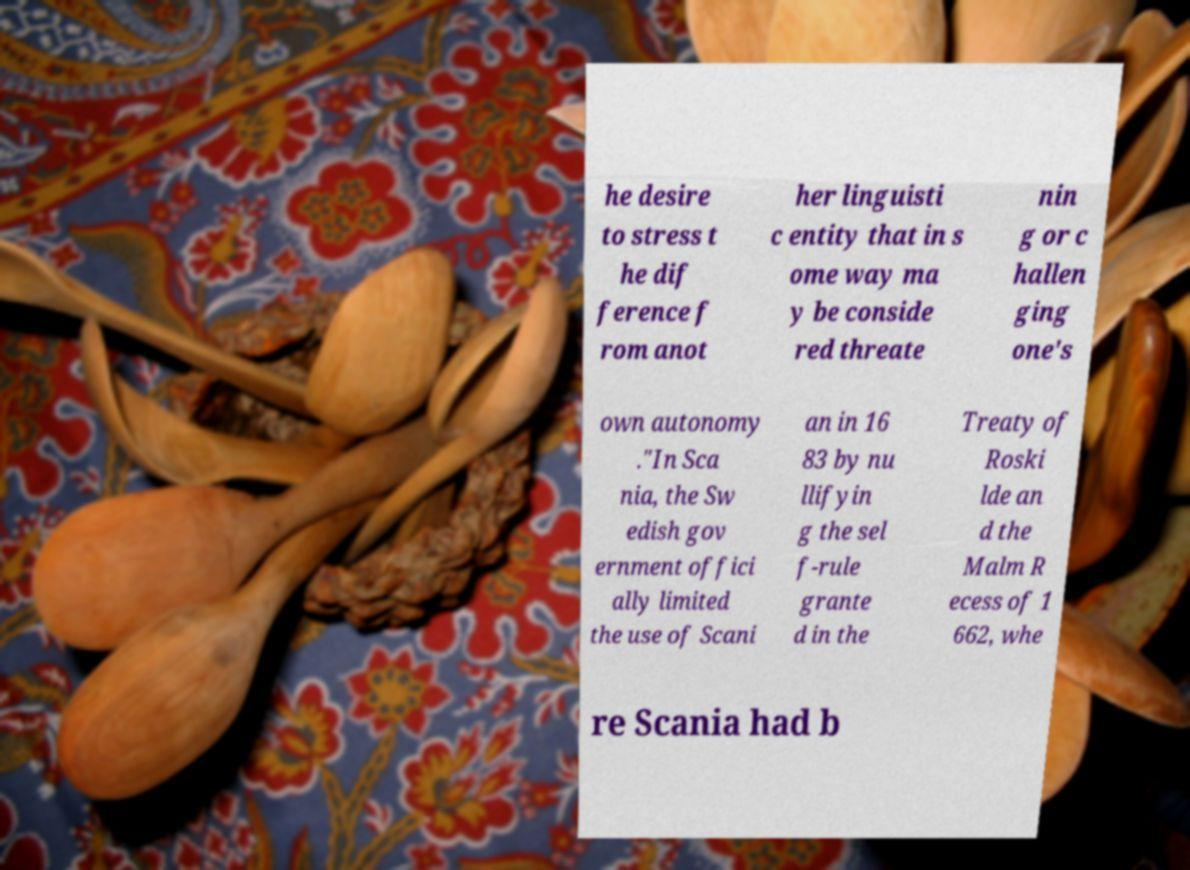For documentation purposes, I need the text within this image transcribed. Could you provide that? he desire to stress t he dif ference f rom anot her linguisti c entity that in s ome way ma y be conside red threate nin g or c hallen ging one's own autonomy ."In Sca nia, the Sw edish gov ernment offici ally limited the use of Scani an in 16 83 by nu llifyin g the sel f-rule grante d in the Treaty of Roski lde an d the Malm R ecess of 1 662, whe re Scania had b 